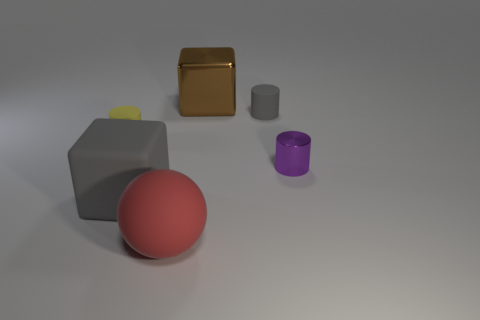Subtract all gray cylinders. How many cylinders are left? 2 Add 2 tiny rubber cylinders. How many objects exist? 8 Subtract all yellow cylinders. How many cylinders are left? 2 Subtract all spheres. How many objects are left? 5 Add 1 small red rubber balls. How many small red rubber balls exist? 1 Subtract 1 gray blocks. How many objects are left? 5 Subtract 2 cylinders. How many cylinders are left? 1 Subtract all red blocks. Subtract all brown cylinders. How many blocks are left? 2 Subtract all green cylinders. How many gray blocks are left? 1 Subtract all big red things. Subtract all blue metallic spheres. How many objects are left? 5 